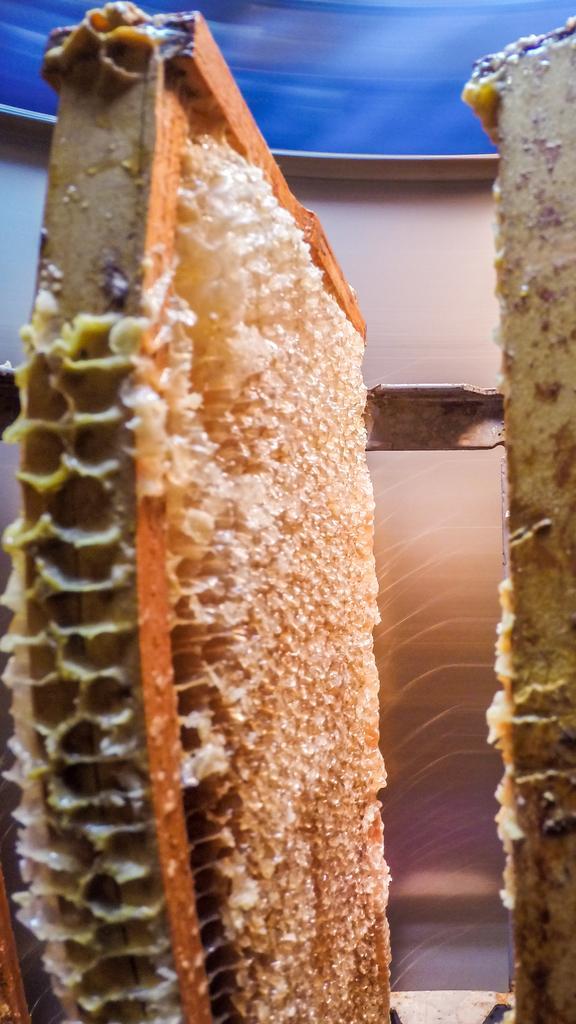Can you describe this image briefly? In this image, we can see a honey bee nest. 